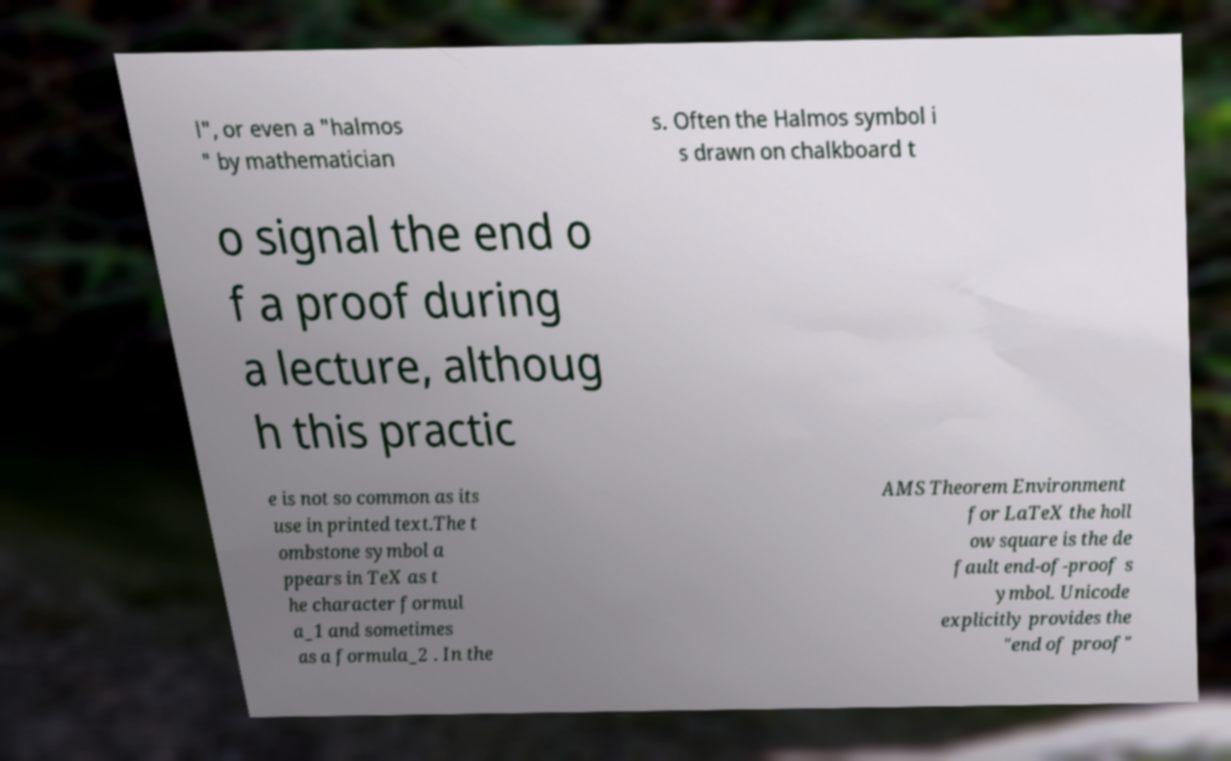For documentation purposes, I need the text within this image transcribed. Could you provide that? l", or even a "halmos " by mathematician s. Often the Halmos symbol i s drawn on chalkboard t o signal the end o f a proof during a lecture, althoug h this practic e is not so common as its use in printed text.The t ombstone symbol a ppears in TeX as t he character formul a_1 and sometimes as a formula_2 . In the AMS Theorem Environment for LaTeX the holl ow square is the de fault end-of-proof s ymbol. Unicode explicitly provides the "end of proof" 